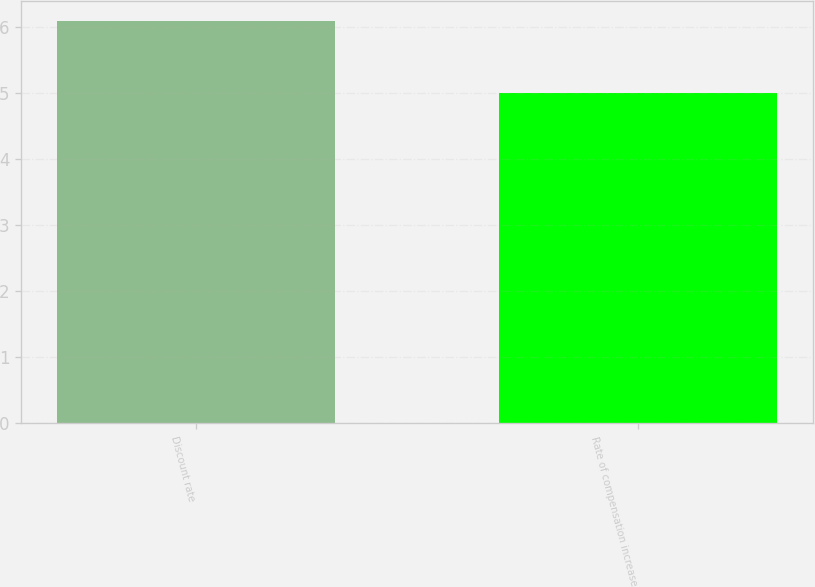Convert chart to OTSL. <chart><loc_0><loc_0><loc_500><loc_500><bar_chart><fcel>Discount rate<fcel>Rate of compensation increase<nl><fcel>6.1<fcel>5<nl></chart> 